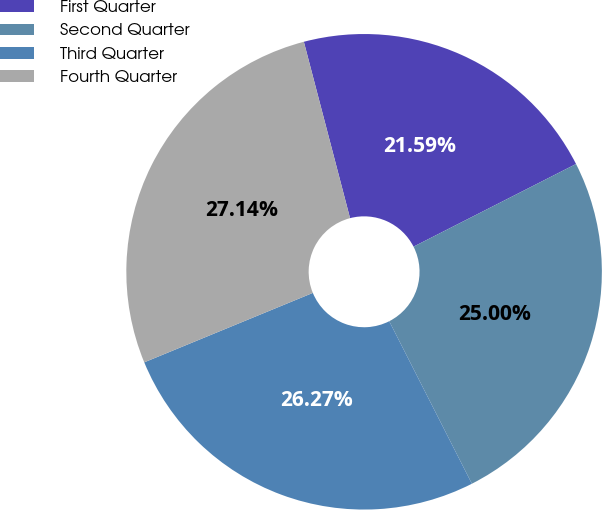Convert chart to OTSL. <chart><loc_0><loc_0><loc_500><loc_500><pie_chart><fcel>First Quarter<fcel>Second Quarter<fcel>Third Quarter<fcel>Fourth Quarter<nl><fcel>21.59%<fcel>25.0%<fcel>26.27%<fcel>27.14%<nl></chart> 